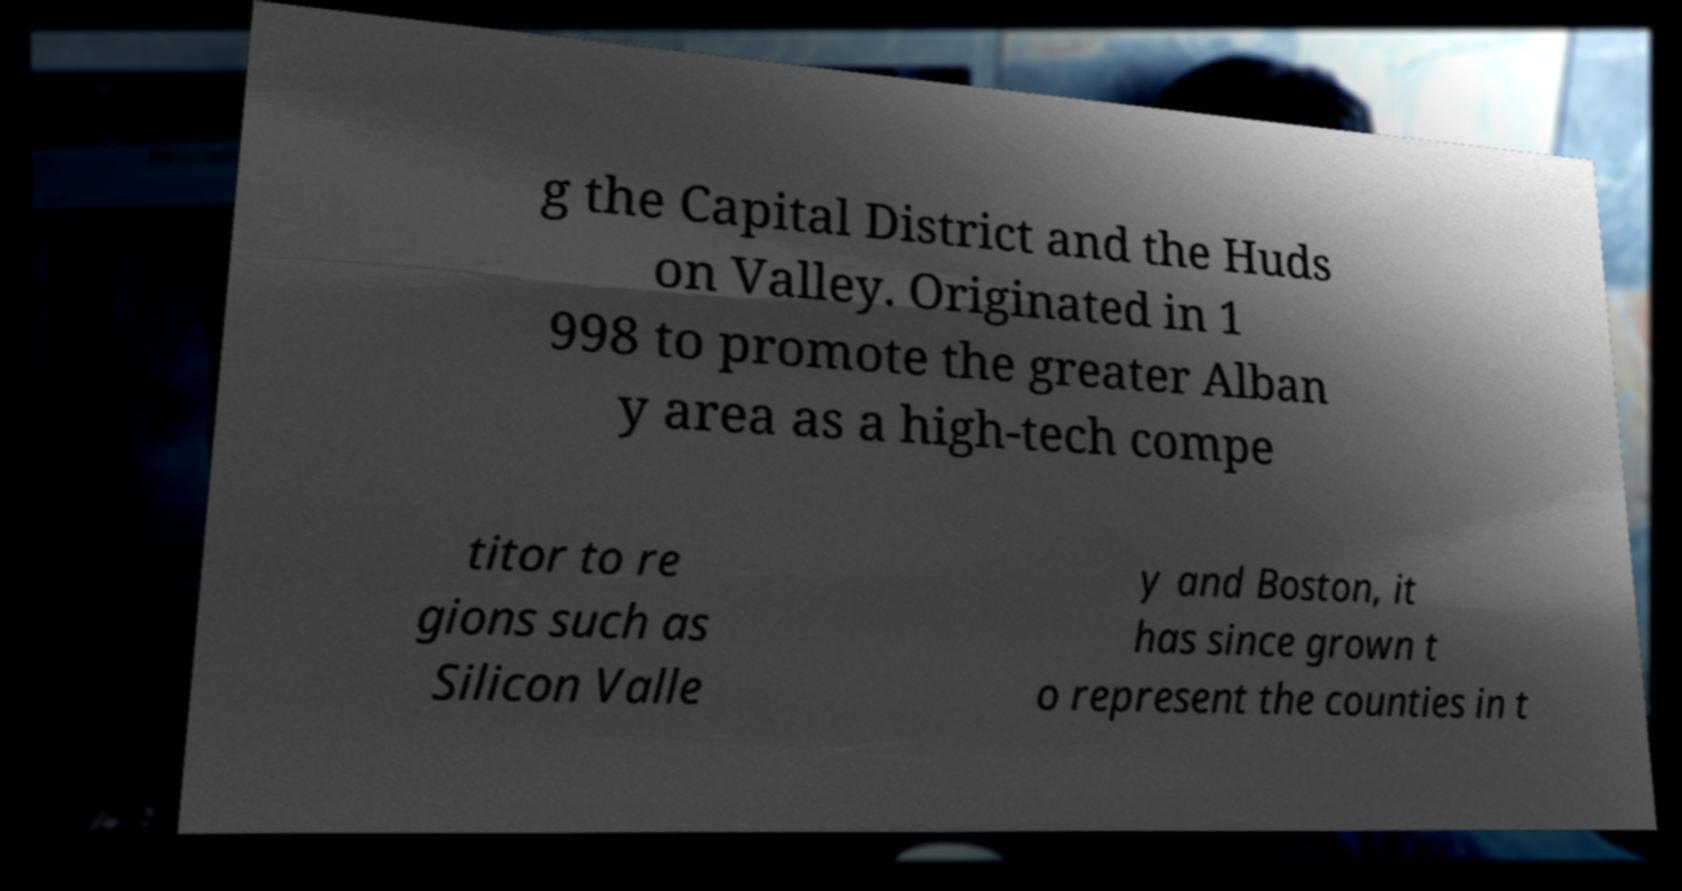Can you accurately transcribe the text from the provided image for me? g the Capital District and the Huds on Valley. Originated in 1 998 to promote the greater Alban y area as a high-tech compe titor to re gions such as Silicon Valle y and Boston, it has since grown t o represent the counties in t 